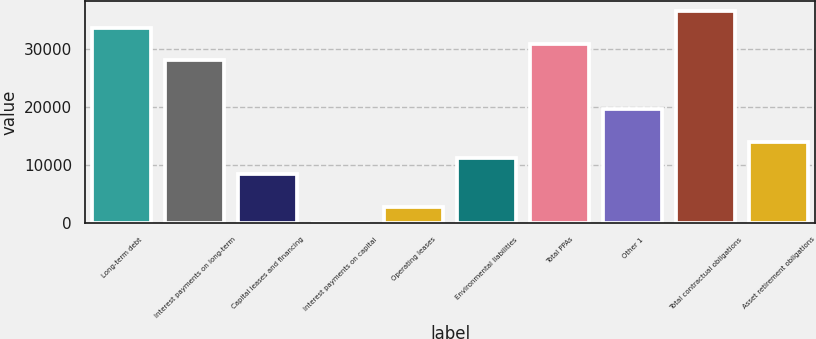Convert chart. <chart><loc_0><loc_0><loc_500><loc_500><bar_chart><fcel>Long-term debt<fcel>Interest payments on long-term<fcel>Capital leases and financing<fcel>Interest payments on capital<fcel>Operating leases<fcel>Environmental liabilities<fcel>Total PPAs<fcel>Other 1<fcel>Total contractual obligations<fcel>Asset retirement obligations<nl><fcel>33695.6<fcel>28085<fcel>8447.9<fcel>32<fcel>2837.3<fcel>11253.2<fcel>30890.3<fcel>19669.1<fcel>36500.9<fcel>14058.5<nl></chart> 